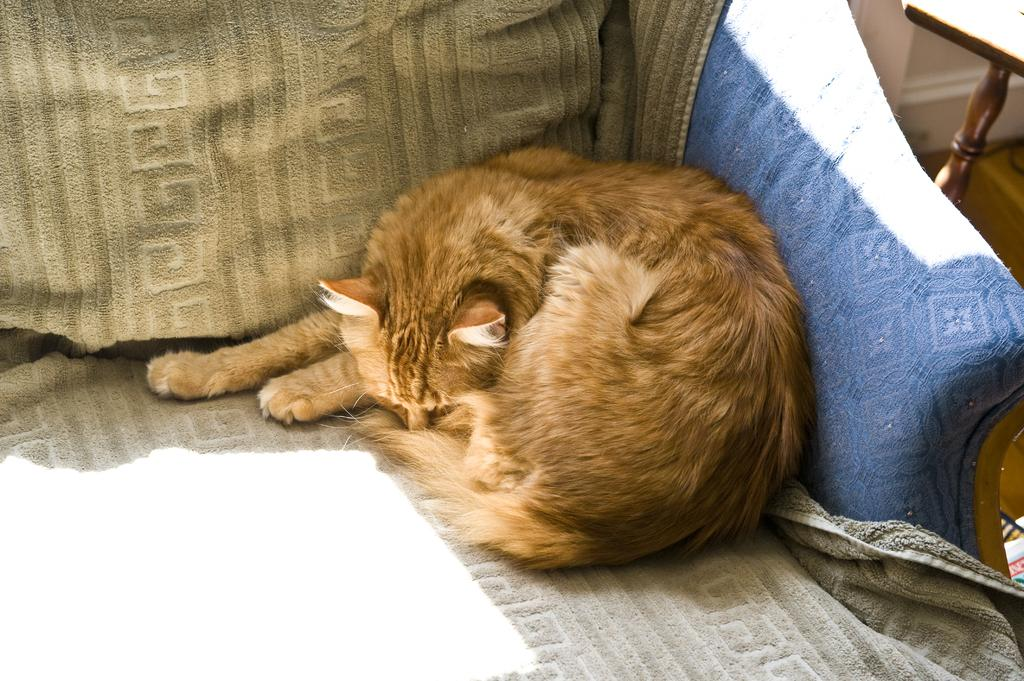What type of animal is in the image? There is a brown color cat in the image. Where is the cat located? The cat is on a couch. What other piece of furniture is visible in the image? There is a table visible in the image. What type of decision can be seen being made by the cat in the image? There is no decision being made by the cat in the image; it is simply sitting on the couch. 